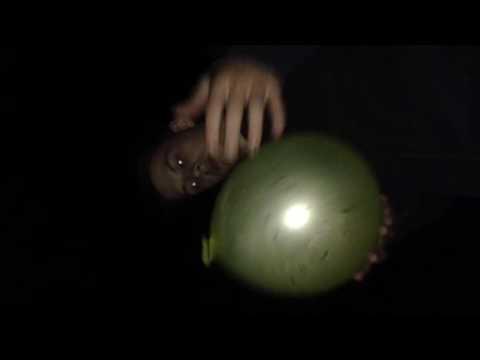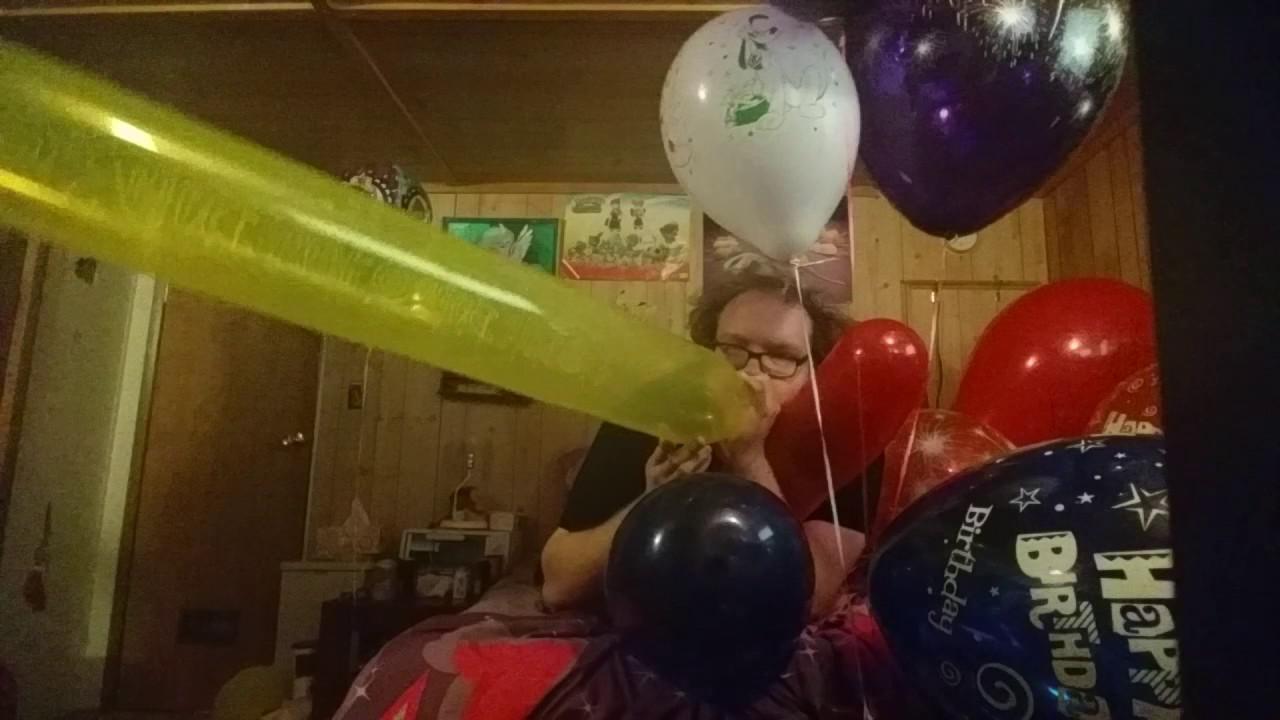The first image is the image on the left, the second image is the image on the right. Examine the images to the left and right. Is the description "Someone is blowing up a balloon in the right image." accurate? Answer yes or no. Yes. The first image is the image on the left, the second image is the image on the right. Given the left and right images, does the statement "There is at least one image with a man blowing up a yellow balloon." hold true? Answer yes or no. Yes. 